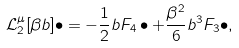Convert formula to latex. <formula><loc_0><loc_0><loc_500><loc_500>\mathcal { L } _ { 2 } ^ { \mu } [ \beta b ] \bullet = - \frac { 1 } { 2 } b F _ { 4 } \bullet + \frac { \beta ^ { 2 } } { 6 } b ^ { 3 } F _ { 3 } \bullet ,</formula> 